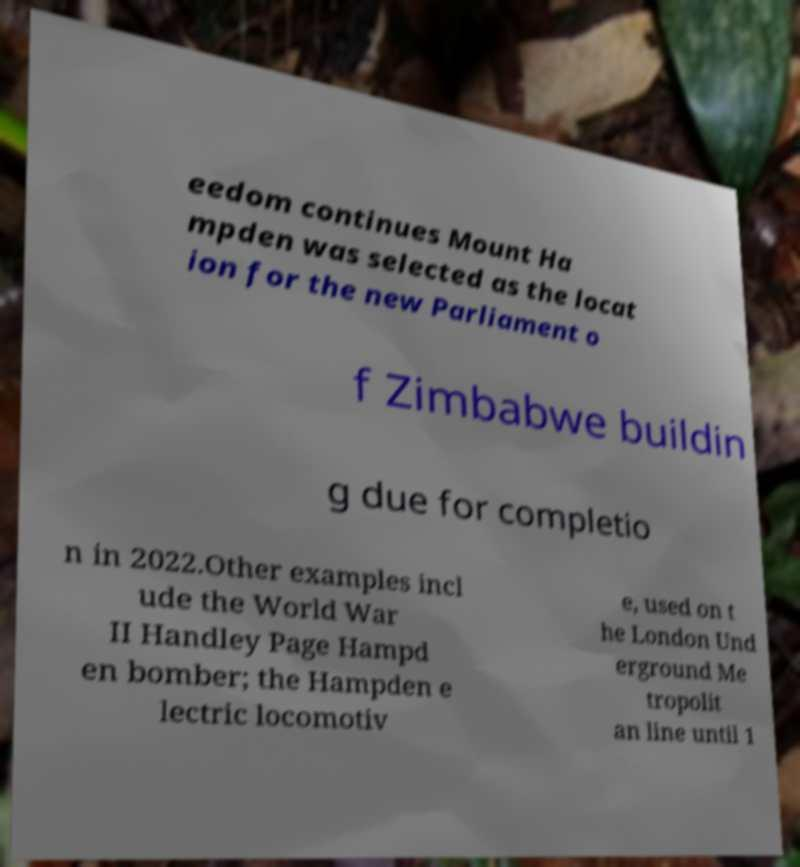Please read and relay the text visible in this image. What does it say? eedom continues Mount Ha mpden was selected as the locat ion for the new Parliament o f Zimbabwe buildin g due for completio n in 2022.Other examples incl ude the World War II Handley Page Hampd en bomber; the Hampden e lectric locomotiv e, used on t he London Und erground Me tropolit an line until 1 